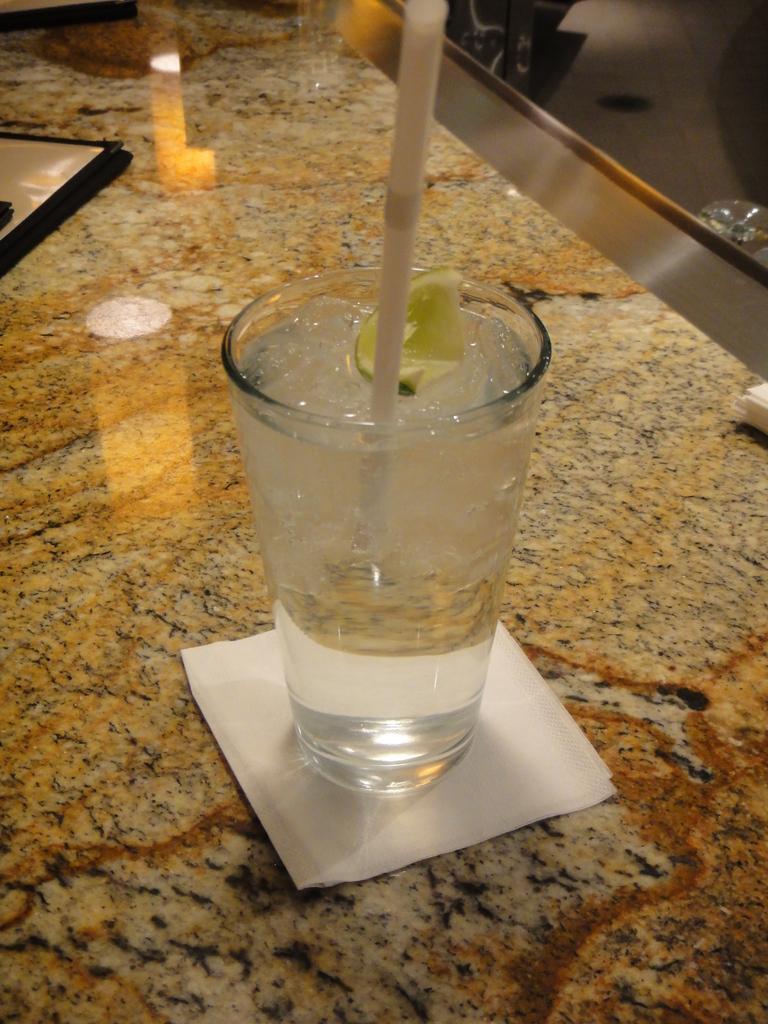Could you give a brief overview of what you see in this image? In this image, we can see a glass on the paper. There is a straw in the glass. 